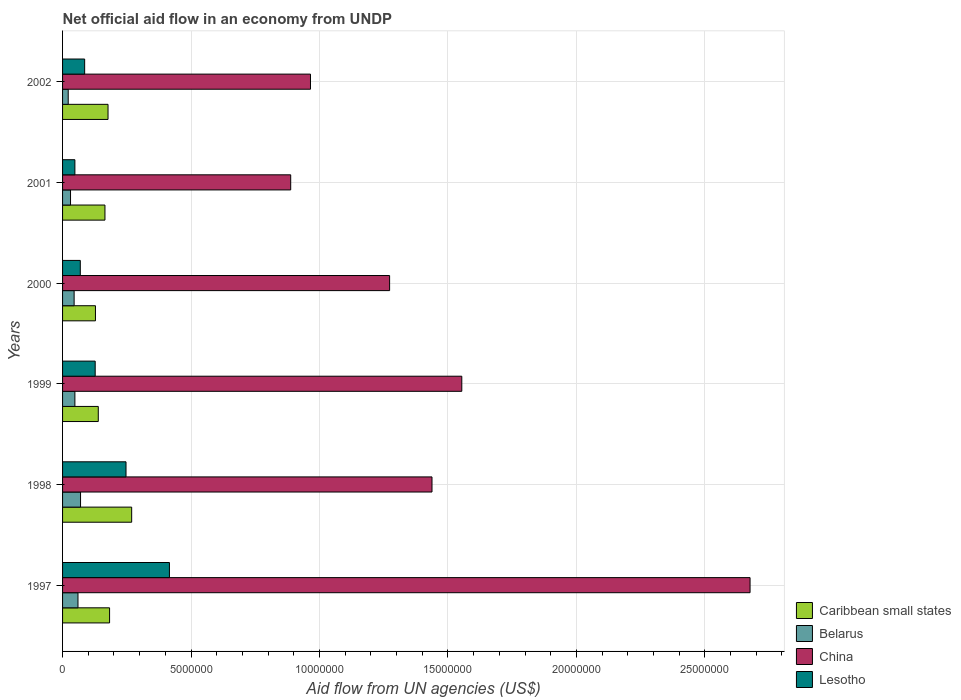How many different coloured bars are there?
Offer a very short reply. 4. Are the number of bars per tick equal to the number of legend labels?
Offer a very short reply. Yes. Are the number of bars on each tick of the Y-axis equal?
Your answer should be compact. Yes. How many bars are there on the 1st tick from the top?
Provide a short and direct response. 4. What is the net official aid flow in Lesotho in 1997?
Offer a terse response. 4.16e+06. Across all years, what is the maximum net official aid flow in China?
Your answer should be very brief. 2.68e+07. Across all years, what is the minimum net official aid flow in Caribbean small states?
Ensure brevity in your answer.  1.28e+06. What is the total net official aid flow in Lesotho in the graph?
Keep it short and to the point. 9.93e+06. What is the difference between the net official aid flow in Lesotho in 1999 and that in 2000?
Ensure brevity in your answer.  5.80e+05. What is the difference between the net official aid flow in China in 1999 and the net official aid flow in Lesotho in 2002?
Give a very brief answer. 1.47e+07. What is the average net official aid flow in China per year?
Ensure brevity in your answer.  1.47e+07. In the year 2001, what is the difference between the net official aid flow in Lesotho and net official aid flow in China?
Provide a succinct answer. -8.40e+06. In how many years, is the net official aid flow in China greater than 13000000 US$?
Give a very brief answer. 3. What is the ratio of the net official aid flow in China in 1997 to that in 2000?
Give a very brief answer. 2.1. Is the net official aid flow in Lesotho in 1998 less than that in 1999?
Keep it short and to the point. No. What is the difference between the highest and the second highest net official aid flow in China?
Give a very brief answer. 1.12e+07. What is the difference between the highest and the lowest net official aid flow in Caribbean small states?
Ensure brevity in your answer.  1.41e+06. In how many years, is the net official aid flow in Belarus greater than the average net official aid flow in Belarus taken over all years?
Your response must be concise. 3. Is the sum of the net official aid flow in Caribbean small states in 1998 and 2001 greater than the maximum net official aid flow in China across all years?
Make the answer very short. No. What does the 2nd bar from the top in 1998 represents?
Provide a short and direct response. China. How many bars are there?
Provide a short and direct response. 24. Are all the bars in the graph horizontal?
Your response must be concise. Yes. What is the difference between two consecutive major ticks on the X-axis?
Your answer should be very brief. 5.00e+06. What is the title of the graph?
Give a very brief answer. Net official aid flow in an economy from UNDP. Does "Hungary" appear as one of the legend labels in the graph?
Your answer should be compact. No. What is the label or title of the X-axis?
Your answer should be compact. Aid flow from UN agencies (US$). What is the label or title of the Y-axis?
Provide a short and direct response. Years. What is the Aid flow from UN agencies (US$) of Caribbean small states in 1997?
Provide a succinct answer. 1.83e+06. What is the Aid flow from UN agencies (US$) of China in 1997?
Your answer should be very brief. 2.68e+07. What is the Aid flow from UN agencies (US$) in Lesotho in 1997?
Your response must be concise. 4.16e+06. What is the Aid flow from UN agencies (US$) in Caribbean small states in 1998?
Your answer should be compact. 2.69e+06. What is the Aid flow from UN agencies (US$) in Belarus in 1998?
Ensure brevity in your answer.  7.00e+05. What is the Aid flow from UN agencies (US$) in China in 1998?
Keep it short and to the point. 1.44e+07. What is the Aid flow from UN agencies (US$) in Lesotho in 1998?
Keep it short and to the point. 2.47e+06. What is the Aid flow from UN agencies (US$) of Caribbean small states in 1999?
Provide a short and direct response. 1.39e+06. What is the Aid flow from UN agencies (US$) in Belarus in 1999?
Your response must be concise. 4.80e+05. What is the Aid flow from UN agencies (US$) of China in 1999?
Offer a terse response. 1.55e+07. What is the Aid flow from UN agencies (US$) of Lesotho in 1999?
Give a very brief answer. 1.27e+06. What is the Aid flow from UN agencies (US$) in Caribbean small states in 2000?
Your answer should be very brief. 1.28e+06. What is the Aid flow from UN agencies (US$) in China in 2000?
Provide a succinct answer. 1.27e+07. What is the Aid flow from UN agencies (US$) of Lesotho in 2000?
Give a very brief answer. 6.90e+05. What is the Aid flow from UN agencies (US$) of Caribbean small states in 2001?
Your response must be concise. 1.65e+06. What is the Aid flow from UN agencies (US$) of Belarus in 2001?
Your answer should be compact. 3.10e+05. What is the Aid flow from UN agencies (US$) in China in 2001?
Make the answer very short. 8.88e+06. What is the Aid flow from UN agencies (US$) of Lesotho in 2001?
Your response must be concise. 4.80e+05. What is the Aid flow from UN agencies (US$) of Caribbean small states in 2002?
Offer a very short reply. 1.77e+06. What is the Aid flow from UN agencies (US$) of Belarus in 2002?
Your answer should be compact. 2.20e+05. What is the Aid flow from UN agencies (US$) in China in 2002?
Give a very brief answer. 9.65e+06. What is the Aid flow from UN agencies (US$) of Lesotho in 2002?
Provide a succinct answer. 8.60e+05. Across all years, what is the maximum Aid flow from UN agencies (US$) of Caribbean small states?
Offer a very short reply. 2.69e+06. Across all years, what is the maximum Aid flow from UN agencies (US$) in China?
Offer a terse response. 2.68e+07. Across all years, what is the maximum Aid flow from UN agencies (US$) in Lesotho?
Provide a succinct answer. 4.16e+06. Across all years, what is the minimum Aid flow from UN agencies (US$) of Caribbean small states?
Offer a very short reply. 1.28e+06. Across all years, what is the minimum Aid flow from UN agencies (US$) of Belarus?
Provide a succinct answer. 2.20e+05. Across all years, what is the minimum Aid flow from UN agencies (US$) in China?
Give a very brief answer. 8.88e+06. What is the total Aid flow from UN agencies (US$) in Caribbean small states in the graph?
Offer a terse response. 1.06e+07. What is the total Aid flow from UN agencies (US$) of Belarus in the graph?
Make the answer very short. 2.76e+06. What is the total Aid flow from UN agencies (US$) in China in the graph?
Provide a short and direct response. 8.79e+07. What is the total Aid flow from UN agencies (US$) of Lesotho in the graph?
Provide a short and direct response. 9.93e+06. What is the difference between the Aid flow from UN agencies (US$) in Caribbean small states in 1997 and that in 1998?
Keep it short and to the point. -8.60e+05. What is the difference between the Aid flow from UN agencies (US$) in China in 1997 and that in 1998?
Your response must be concise. 1.24e+07. What is the difference between the Aid flow from UN agencies (US$) of Lesotho in 1997 and that in 1998?
Ensure brevity in your answer.  1.69e+06. What is the difference between the Aid flow from UN agencies (US$) in China in 1997 and that in 1999?
Your answer should be very brief. 1.12e+07. What is the difference between the Aid flow from UN agencies (US$) in Lesotho in 1997 and that in 1999?
Provide a succinct answer. 2.89e+06. What is the difference between the Aid flow from UN agencies (US$) in Caribbean small states in 1997 and that in 2000?
Provide a succinct answer. 5.50e+05. What is the difference between the Aid flow from UN agencies (US$) in China in 1997 and that in 2000?
Your answer should be very brief. 1.40e+07. What is the difference between the Aid flow from UN agencies (US$) of Lesotho in 1997 and that in 2000?
Offer a very short reply. 3.47e+06. What is the difference between the Aid flow from UN agencies (US$) of Caribbean small states in 1997 and that in 2001?
Ensure brevity in your answer.  1.80e+05. What is the difference between the Aid flow from UN agencies (US$) in Belarus in 1997 and that in 2001?
Your response must be concise. 2.90e+05. What is the difference between the Aid flow from UN agencies (US$) of China in 1997 and that in 2001?
Offer a very short reply. 1.79e+07. What is the difference between the Aid flow from UN agencies (US$) in Lesotho in 1997 and that in 2001?
Ensure brevity in your answer.  3.68e+06. What is the difference between the Aid flow from UN agencies (US$) of China in 1997 and that in 2002?
Provide a succinct answer. 1.71e+07. What is the difference between the Aid flow from UN agencies (US$) in Lesotho in 1997 and that in 2002?
Give a very brief answer. 3.30e+06. What is the difference between the Aid flow from UN agencies (US$) of Caribbean small states in 1998 and that in 1999?
Keep it short and to the point. 1.30e+06. What is the difference between the Aid flow from UN agencies (US$) in China in 1998 and that in 1999?
Provide a short and direct response. -1.16e+06. What is the difference between the Aid flow from UN agencies (US$) in Lesotho in 1998 and that in 1999?
Provide a succinct answer. 1.20e+06. What is the difference between the Aid flow from UN agencies (US$) in Caribbean small states in 1998 and that in 2000?
Give a very brief answer. 1.41e+06. What is the difference between the Aid flow from UN agencies (US$) in Belarus in 1998 and that in 2000?
Provide a short and direct response. 2.50e+05. What is the difference between the Aid flow from UN agencies (US$) in China in 1998 and that in 2000?
Keep it short and to the point. 1.65e+06. What is the difference between the Aid flow from UN agencies (US$) in Lesotho in 1998 and that in 2000?
Make the answer very short. 1.78e+06. What is the difference between the Aid flow from UN agencies (US$) of Caribbean small states in 1998 and that in 2001?
Offer a very short reply. 1.04e+06. What is the difference between the Aid flow from UN agencies (US$) in China in 1998 and that in 2001?
Make the answer very short. 5.50e+06. What is the difference between the Aid flow from UN agencies (US$) of Lesotho in 1998 and that in 2001?
Your answer should be very brief. 1.99e+06. What is the difference between the Aid flow from UN agencies (US$) in Caribbean small states in 1998 and that in 2002?
Offer a very short reply. 9.20e+05. What is the difference between the Aid flow from UN agencies (US$) in China in 1998 and that in 2002?
Your answer should be very brief. 4.73e+06. What is the difference between the Aid flow from UN agencies (US$) in Lesotho in 1998 and that in 2002?
Provide a succinct answer. 1.61e+06. What is the difference between the Aid flow from UN agencies (US$) in Belarus in 1999 and that in 2000?
Your answer should be very brief. 3.00e+04. What is the difference between the Aid flow from UN agencies (US$) in China in 1999 and that in 2000?
Offer a very short reply. 2.81e+06. What is the difference between the Aid flow from UN agencies (US$) of Lesotho in 1999 and that in 2000?
Your answer should be very brief. 5.80e+05. What is the difference between the Aid flow from UN agencies (US$) in China in 1999 and that in 2001?
Offer a terse response. 6.66e+06. What is the difference between the Aid flow from UN agencies (US$) in Lesotho in 1999 and that in 2001?
Your answer should be very brief. 7.90e+05. What is the difference between the Aid flow from UN agencies (US$) in Caribbean small states in 1999 and that in 2002?
Provide a short and direct response. -3.80e+05. What is the difference between the Aid flow from UN agencies (US$) in China in 1999 and that in 2002?
Provide a succinct answer. 5.89e+06. What is the difference between the Aid flow from UN agencies (US$) in Caribbean small states in 2000 and that in 2001?
Your response must be concise. -3.70e+05. What is the difference between the Aid flow from UN agencies (US$) in Belarus in 2000 and that in 2001?
Offer a very short reply. 1.40e+05. What is the difference between the Aid flow from UN agencies (US$) in China in 2000 and that in 2001?
Your answer should be very brief. 3.85e+06. What is the difference between the Aid flow from UN agencies (US$) of Caribbean small states in 2000 and that in 2002?
Offer a terse response. -4.90e+05. What is the difference between the Aid flow from UN agencies (US$) of Belarus in 2000 and that in 2002?
Your response must be concise. 2.30e+05. What is the difference between the Aid flow from UN agencies (US$) in China in 2000 and that in 2002?
Make the answer very short. 3.08e+06. What is the difference between the Aid flow from UN agencies (US$) of China in 2001 and that in 2002?
Keep it short and to the point. -7.70e+05. What is the difference between the Aid flow from UN agencies (US$) of Lesotho in 2001 and that in 2002?
Offer a terse response. -3.80e+05. What is the difference between the Aid flow from UN agencies (US$) of Caribbean small states in 1997 and the Aid flow from UN agencies (US$) of Belarus in 1998?
Give a very brief answer. 1.13e+06. What is the difference between the Aid flow from UN agencies (US$) of Caribbean small states in 1997 and the Aid flow from UN agencies (US$) of China in 1998?
Your answer should be very brief. -1.26e+07. What is the difference between the Aid flow from UN agencies (US$) of Caribbean small states in 1997 and the Aid flow from UN agencies (US$) of Lesotho in 1998?
Make the answer very short. -6.40e+05. What is the difference between the Aid flow from UN agencies (US$) in Belarus in 1997 and the Aid flow from UN agencies (US$) in China in 1998?
Provide a succinct answer. -1.38e+07. What is the difference between the Aid flow from UN agencies (US$) in Belarus in 1997 and the Aid flow from UN agencies (US$) in Lesotho in 1998?
Provide a succinct answer. -1.87e+06. What is the difference between the Aid flow from UN agencies (US$) of China in 1997 and the Aid flow from UN agencies (US$) of Lesotho in 1998?
Your response must be concise. 2.43e+07. What is the difference between the Aid flow from UN agencies (US$) of Caribbean small states in 1997 and the Aid flow from UN agencies (US$) of Belarus in 1999?
Give a very brief answer. 1.35e+06. What is the difference between the Aid flow from UN agencies (US$) of Caribbean small states in 1997 and the Aid flow from UN agencies (US$) of China in 1999?
Your answer should be compact. -1.37e+07. What is the difference between the Aid flow from UN agencies (US$) in Caribbean small states in 1997 and the Aid flow from UN agencies (US$) in Lesotho in 1999?
Provide a short and direct response. 5.60e+05. What is the difference between the Aid flow from UN agencies (US$) in Belarus in 1997 and the Aid flow from UN agencies (US$) in China in 1999?
Your response must be concise. -1.49e+07. What is the difference between the Aid flow from UN agencies (US$) in Belarus in 1997 and the Aid flow from UN agencies (US$) in Lesotho in 1999?
Give a very brief answer. -6.70e+05. What is the difference between the Aid flow from UN agencies (US$) of China in 1997 and the Aid flow from UN agencies (US$) of Lesotho in 1999?
Offer a very short reply. 2.55e+07. What is the difference between the Aid flow from UN agencies (US$) in Caribbean small states in 1997 and the Aid flow from UN agencies (US$) in Belarus in 2000?
Your answer should be compact. 1.38e+06. What is the difference between the Aid flow from UN agencies (US$) in Caribbean small states in 1997 and the Aid flow from UN agencies (US$) in China in 2000?
Give a very brief answer. -1.09e+07. What is the difference between the Aid flow from UN agencies (US$) of Caribbean small states in 1997 and the Aid flow from UN agencies (US$) of Lesotho in 2000?
Your response must be concise. 1.14e+06. What is the difference between the Aid flow from UN agencies (US$) in Belarus in 1997 and the Aid flow from UN agencies (US$) in China in 2000?
Your answer should be very brief. -1.21e+07. What is the difference between the Aid flow from UN agencies (US$) of Belarus in 1997 and the Aid flow from UN agencies (US$) of Lesotho in 2000?
Make the answer very short. -9.00e+04. What is the difference between the Aid flow from UN agencies (US$) of China in 1997 and the Aid flow from UN agencies (US$) of Lesotho in 2000?
Keep it short and to the point. 2.61e+07. What is the difference between the Aid flow from UN agencies (US$) in Caribbean small states in 1997 and the Aid flow from UN agencies (US$) in Belarus in 2001?
Keep it short and to the point. 1.52e+06. What is the difference between the Aid flow from UN agencies (US$) in Caribbean small states in 1997 and the Aid flow from UN agencies (US$) in China in 2001?
Provide a short and direct response. -7.05e+06. What is the difference between the Aid flow from UN agencies (US$) of Caribbean small states in 1997 and the Aid flow from UN agencies (US$) of Lesotho in 2001?
Your answer should be very brief. 1.35e+06. What is the difference between the Aid flow from UN agencies (US$) in Belarus in 1997 and the Aid flow from UN agencies (US$) in China in 2001?
Ensure brevity in your answer.  -8.28e+06. What is the difference between the Aid flow from UN agencies (US$) of China in 1997 and the Aid flow from UN agencies (US$) of Lesotho in 2001?
Your answer should be very brief. 2.63e+07. What is the difference between the Aid flow from UN agencies (US$) of Caribbean small states in 1997 and the Aid flow from UN agencies (US$) of Belarus in 2002?
Make the answer very short. 1.61e+06. What is the difference between the Aid flow from UN agencies (US$) in Caribbean small states in 1997 and the Aid flow from UN agencies (US$) in China in 2002?
Your answer should be compact. -7.82e+06. What is the difference between the Aid flow from UN agencies (US$) of Caribbean small states in 1997 and the Aid flow from UN agencies (US$) of Lesotho in 2002?
Offer a very short reply. 9.70e+05. What is the difference between the Aid flow from UN agencies (US$) of Belarus in 1997 and the Aid flow from UN agencies (US$) of China in 2002?
Offer a very short reply. -9.05e+06. What is the difference between the Aid flow from UN agencies (US$) in China in 1997 and the Aid flow from UN agencies (US$) in Lesotho in 2002?
Your response must be concise. 2.59e+07. What is the difference between the Aid flow from UN agencies (US$) of Caribbean small states in 1998 and the Aid flow from UN agencies (US$) of Belarus in 1999?
Give a very brief answer. 2.21e+06. What is the difference between the Aid flow from UN agencies (US$) in Caribbean small states in 1998 and the Aid flow from UN agencies (US$) in China in 1999?
Offer a very short reply. -1.28e+07. What is the difference between the Aid flow from UN agencies (US$) in Caribbean small states in 1998 and the Aid flow from UN agencies (US$) in Lesotho in 1999?
Provide a succinct answer. 1.42e+06. What is the difference between the Aid flow from UN agencies (US$) in Belarus in 1998 and the Aid flow from UN agencies (US$) in China in 1999?
Provide a short and direct response. -1.48e+07. What is the difference between the Aid flow from UN agencies (US$) of Belarus in 1998 and the Aid flow from UN agencies (US$) of Lesotho in 1999?
Your answer should be compact. -5.70e+05. What is the difference between the Aid flow from UN agencies (US$) in China in 1998 and the Aid flow from UN agencies (US$) in Lesotho in 1999?
Offer a terse response. 1.31e+07. What is the difference between the Aid flow from UN agencies (US$) of Caribbean small states in 1998 and the Aid flow from UN agencies (US$) of Belarus in 2000?
Give a very brief answer. 2.24e+06. What is the difference between the Aid flow from UN agencies (US$) in Caribbean small states in 1998 and the Aid flow from UN agencies (US$) in China in 2000?
Provide a succinct answer. -1.00e+07. What is the difference between the Aid flow from UN agencies (US$) of Belarus in 1998 and the Aid flow from UN agencies (US$) of China in 2000?
Keep it short and to the point. -1.20e+07. What is the difference between the Aid flow from UN agencies (US$) of China in 1998 and the Aid flow from UN agencies (US$) of Lesotho in 2000?
Your answer should be very brief. 1.37e+07. What is the difference between the Aid flow from UN agencies (US$) of Caribbean small states in 1998 and the Aid flow from UN agencies (US$) of Belarus in 2001?
Provide a short and direct response. 2.38e+06. What is the difference between the Aid flow from UN agencies (US$) of Caribbean small states in 1998 and the Aid flow from UN agencies (US$) of China in 2001?
Give a very brief answer. -6.19e+06. What is the difference between the Aid flow from UN agencies (US$) in Caribbean small states in 1998 and the Aid flow from UN agencies (US$) in Lesotho in 2001?
Your answer should be very brief. 2.21e+06. What is the difference between the Aid flow from UN agencies (US$) of Belarus in 1998 and the Aid flow from UN agencies (US$) of China in 2001?
Offer a terse response. -8.18e+06. What is the difference between the Aid flow from UN agencies (US$) in China in 1998 and the Aid flow from UN agencies (US$) in Lesotho in 2001?
Your answer should be compact. 1.39e+07. What is the difference between the Aid flow from UN agencies (US$) in Caribbean small states in 1998 and the Aid flow from UN agencies (US$) in Belarus in 2002?
Your answer should be compact. 2.47e+06. What is the difference between the Aid flow from UN agencies (US$) of Caribbean small states in 1998 and the Aid flow from UN agencies (US$) of China in 2002?
Give a very brief answer. -6.96e+06. What is the difference between the Aid flow from UN agencies (US$) of Caribbean small states in 1998 and the Aid flow from UN agencies (US$) of Lesotho in 2002?
Provide a succinct answer. 1.83e+06. What is the difference between the Aid flow from UN agencies (US$) of Belarus in 1998 and the Aid flow from UN agencies (US$) of China in 2002?
Give a very brief answer. -8.95e+06. What is the difference between the Aid flow from UN agencies (US$) of China in 1998 and the Aid flow from UN agencies (US$) of Lesotho in 2002?
Keep it short and to the point. 1.35e+07. What is the difference between the Aid flow from UN agencies (US$) of Caribbean small states in 1999 and the Aid flow from UN agencies (US$) of Belarus in 2000?
Provide a succinct answer. 9.40e+05. What is the difference between the Aid flow from UN agencies (US$) of Caribbean small states in 1999 and the Aid flow from UN agencies (US$) of China in 2000?
Offer a terse response. -1.13e+07. What is the difference between the Aid flow from UN agencies (US$) in Caribbean small states in 1999 and the Aid flow from UN agencies (US$) in Lesotho in 2000?
Keep it short and to the point. 7.00e+05. What is the difference between the Aid flow from UN agencies (US$) of Belarus in 1999 and the Aid flow from UN agencies (US$) of China in 2000?
Your answer should be very brief. -1.22e+07. What is the difference between the Aid flow from UN agencies (US$) in Belarus in 1999 and the Aid flow from UN agencies (US$) in Lesotho in 2000?
Offer a very short reply. -2.10e+05. What is the difference between the Aid flow from UN agencies (US$) of China in 1999 and the Aid flow from UN agencies (US$) of Lesotho in 2000?
Provide a short and direct response. 1.48e+07. What is the difference between the Aid flow from UN agencies (US$) in Caribbean small states in 1999 and the Aid flow from UN agencies (US$) in Belarus in 2001?
Give a very brief answer. 1.08e+06. What is the difference between the Aid flow from UN agencies (US$) of Caribbean small states in 1999 and the Aid flow from UN agencies (US$) of China in 2001?
Give a very brief answer. -7.49e+06. What is the difference between the Aid flow from UN agencies (US$) of Caribbean small states in 1999 and the Aid flow from UN agencies (US$) of Lesotho in 2001?
Ensure brevity in your answer.  9.10e+05. What is the difference between the Aid flow from UN agencies (US$) of Belarus in 1999 and the Aid flow from UN agencies (US$) of China in 2001?
Keep it short and to the point. -8.40e+06. What is the difference between the Aid flow from UN agencies (US$) in China in 1999 and the Aid flow from UN agencies (US$) in Lesotho in 2001?
Your response must be concise. 1.51e+07. What is the difference between the Aid flow from UN agencies (US$) of Caribbean small states in 1999 and the Aid flow from UN agencies (US$) of Belarus in 2002?
Ensure brevity in your answer.  1.17e+06. What is the difference between the Aid flow from UN agencies (US$) in Caribbean small states in 1999 and the Aid flow from UN agencies (US$) in China in 2002?
Your response must be concise. -8.26e+06. What is the difference between the Aid flow from UN agencies (US$) of Caribbean small states in 1999 and the Aid flow from UN agencies (US$) of Lesotho in 2002?
Offer a very short reply. 5.30e+05. What is the difference between the Aid flow from UN agencies (US$) in Belarus in 1999 and the Aid flow from UN agencies (US$) in China in 2002?
Your answer should be compact. -9.17e+06. What is the difference between the Aid flow from UN agencies (US$) of Belarus in 1999 and the Aid flow from UN agencies (US$) of Lesotho in 2002?
Keep it short and to the point. -3.80e+05. What is the difference between the Aid flow from UN agencies (US$) of China in 1999 and the Aid flow from UN agencies (US$) of Lesotho in 2002?
Give a very brief answer. 1.47e+07. What is the difference between the Aid flow from UN agencies (US$) in Caribbean small states in 2000 and the Aid flow from UN agencies (US$) in Belarus in 2001?
Make the answer very short. 9.70e+05. What is the difference between the Aid flow from UN agencies (US$) of Caribbean small states in 2000 and the Aid flow from UN agencies (US$) of China in 2001?
Offer a very short reply. -7.60e+06. What is the difference between the Aid flow from UN agencies (US$) in Caribbean small states in 2000 and the Aid flow from UN agencies (US$) in Lesotho in 2001?
Ensure brevity in your answer.  8.00e+05. What is the difference between the Aid flow from UN agencies (US$) in Belarus in 2000 and the Aid flow from UN agencies (US$) in China in 2001?
Your answer should be compact. -8.43e+06. What is the difference between the Aid flow from UN agencies (US$) in China in 2000 and the Aid flow from UN agencies (US$) in Lesotho in 2001?
Give a very brief answer. 1.22e+07. What is the difference between the Aid flow from UN agencies (US$) of Caribbean small states in 2000 and the Aid flow from UN agencies (US$) of Belarus in 2002?
Provide a short and direct response. 1.06e+06. What is the difference between the Aid flow from UN agencies (US$) in Caribbean small states in 2000 and the Aid flow from UN agencies (US$) in China in 2002?
Your response must be concise. -8.37e+06. What is the difference between the Aid flow from UN agencies (US$) in Caribbean small states in 2000 and the Aid flow from UN agencies (US$) in Lesotho in 2002?
Make the answer very short. 4.20e+05. What is the difference between the Aid flow from UN agencies (US$) of Belarus in 2000 and the Aid flow from UN agencies (US$) of China in 2002?
Your answer should be compact. -9.20e+06. What is the difference between the Aid flow from UN agencies (US$) of Belarus in 2000 and the Aid flow from UN agencies (US$) of Lesotho in 2002?
Provide a succinct answer. -4.10e+05. What is the difference between the Aid flow from UN agencies (US$) in China in 2000 and the Aid flow from UN agencies (US$) in Lesotho in 2002?
Your answer should be compact. 1.19e+07. What is the difference between the Aid flow from UN agencies (US$) in Caribbean small states in 2001 and the Aid flow from UN agencies (US$) in Belarus in 2002?
Make the answer very short. 1.43e+06. What is the difference between the Aid flow from UN agencies (US$) in Caribbean small states in 2001 and the Aid flow from UN agencies (US$) in China in 2002?
Make the answer very short. -8.00e+06. What is the difference between the Aid flow from UN agencies (US$) in Caribbean small states in 2001 and the Aid flow from UN agencies (US$) in Lesotho in 2002?
Ensure brevity in your answer.  7.90e+05. What is the difference between the Aid flow from UN agencies (US$) in Belarus in 2001 and the Aid flow from UN agencies (US$) in China in 2002?
Ensure brevity in your answer.  -9.34e+06. What is the difference between the Aid flow from UN agencies (US$) in Belarus in 2001 and the Aid flow from UN agencies (US$) in Lesotho in 2002?
Provide a succinct answer. -5.50e+05. What is the difference between the Aid flow from UN agencies (US$) of China in 2001 and the Aid flow from UN agencies (US$) of Lesotho in 2002?
Ensure brevity in your answer.  8.02e+06. What is the average Aid flow from UN agencies (US$) in Caribbean small states per year?
Ensure brevity in your answer.  1.77e+06. What is the average Aid flow from UN agencies (US$) of Belarus per year?
Your response must be concise. 4.60e+05. What is the average Aid flow from UN agencies (US$) in China per year?
Ensure brevity in your answer.  1.47e+07. What is the average Aid flow from UN agencies (US$) in Lesotho per year?
Offer a terse response. 1.66e+06. In the year 1997, what is the difference between the Aid flow from UN agencies (US$) in Caribbean small states and Aid flow from UN agencies (US$) in Belarus?
Your response must be concise. 1.23e+06. In the year 1997, what is the difference between the Aid flow from UN agencies (US$) of Caribbean small states and Aid flow from UN agencies (US$) of China?
Your answer should be compact. -2.49e+07. In the year 1997, what is the difference between the Aid flow from UN agencies (US$) in Caribbean small states and Aid flow from UN agencies (US$) in Lesotho?
Your answer should be very brief. -2.33e+06. In the year 1997, what is the difference between the Aid flow from UN agencies (US$) of Belarus and Aid flow from UN agencies (US$) of China?
Give a very brief answer. -2.62e+07. In the year 1997, what is the difference between the Aid flow from UN agencies (US$) in Belarus and Aid flow from UN agencies (US$) in Lesotho?
Offer a terse response. -3.56e+06. In the year 1997, what is the difference between the Aid flow from UN agencies (US$) of China and Aid flow from UN agencies (US$) of Lesotho?
Provide a succinct answer. 2.26e+07. In the year 1998, what is the difference between the Aid flow from UN agencies (US$) in Caribbean small states and Aid flow from UN agencies (US$) in Belarus?
Offer a very short reply. 1.99e+06. In the year 1998, what is the difference between the Aid flow from UN agencies (US$) of Caribbean small states and Aid flow from UN agencies (US$) of China?
Ensure brevity in your answer.  -1.17e+07. In the year 1998, what is the difference between the Aid flow from UN agencies (US$) in Caribbean small states and Aid flow from UN agencies (US$) in Lesotho?
Keep it short and to the point. 2.20e+05. In the year 1998, what is the difference between the Aid flow from UN agencies (US$) in Belarus and Aid flow from UN agencies (US$) in China?
Make the answer very short. -1.37e+07. In the year 1998, what is the difference between the Aid flow from UN agencies (US$) in Belarus and Aid flow from UN agencies (US$) in Lesotho?
Offer a terse response. -1.77e+06. In the year 1998, what is the difference between the Aid flow from UN agencies (US$) in China and Aid flow from UN agencies (US$) in Lesotho?
Your response must be concise. 1.19e+07. In the year 1999, what is the difference between the Aid flow from UN agencies (US$) in Caribbean small states and Aid flow from UN agencies (US$) in Belarus?
Your answer should be compact. 9.10e+05. In the year 1999, what is the difference between the Aid flow from UN agencies (US$) of Caribbean small states and Aid flow from UN agencies (US$) of China?
Ensure brevity in your answer.  -1.42e+07. In the year 1999, what is the difference between the Aid flow from UN agencies (US$) of Caribbean small states and Aid flow from UN agencies (US$) of Lesotho?
Keep it short and to the point. 1.20e+05. In the year 1999, what is the difference between the Aid flow from UN agencies (US$) in Belarus and Aid flow from UN agencies (US$) in China?
Make the answer very short. -1.51e+07. In the year 1999, what is the difference between the Aid flow from UN agencies (US$) of Belarus and Aid flow from UN agencies (US$) of Lesotho?
Your response must be concise. -7.90e+05. In the year 1999, what is the difference between the Aid flow from UN agencies (US$) of China and Aid flow from UN agencies (US$) of Lesotho?
Provide a short and direct response. 1.43e+07. In the year 2000, what is the difference between the Aid flow from UN agencies (US$) in Caribbean small states and Aid flow from UN agencies (US$) in Belarus?
Ensure brevity in your answer.  8.30e+05. In the year 2000, what is the difference between the Aid flow from UN agencies (US$) of Caribbean small states and Aid flow from UN agencies (US$) of China?
Provide a short and direct response. -1.14e+07. In the year 2000, what is the difference between the Aid flow from UN agencies (US$) of Caribbean small states and Aid flow from UN agencies (US$) of Lesotho?
Offer a terse response. 5.90e+05. In the year 2000, what is the difference between the Aid flow from UN agencies (US$) of Belarus and Aid flow from UN agencies (US$) of China?
Your answer should be very brief. -1.23e+07. In the year 2000, what is the difference between the Aid flow from UN agencies (US$) of China and Aid flow from UN agencies (US$) of Lesotho?
Keep it short and to the point. 1.20e+07. In the year 2001, what is the difference between the Aid flow from UN agencies (US$) of Caribbean small states and Aid flow from UN agencies (US$) of Belarus?
Your answer should be compact. 1.34e+06. In the year 2001, what is the difference between the Aid flow from UN agencies (US$) in Caribbean small states and Aid flow from UN agencies (US$) in China?
Offer a very short reply. -7.23e+06. In the year 2001, what is the difference between the Aid flow from UN agencies (US$) in Caribbean small states and Aid flow from UN agencies (US$) in Lesotho?
Offer a terse response. 1.17e+06. In the year 2001, what is the difference between the Aid flow from UN agencies (US$) of Belarus and Aid flow from UN agencies (US$) of China?
Keep it short and to the point. -8.57e+06. In the year 2001, what is the difference between the Aid flow from UN agencies (US$) in Belarus and Aid flow from UN agencies (US$) in Lesotho?
Give a very brief answer. -1.70e+05. In the year 2001, what is the difference between the Aid flow from UN agencies (US$) of China and Aid flow from UN agencies (US$) of Lesotho?
Your answer should be compact. 8.40e+06. In the year 2002, what is the difference between the Aid flow from UN agencies (US$) in Caribbean small states and Aid flow from UN agencies (US$) in Belarus?
Ensure brevity in your answer.  1.55e+06. In the year 2002, what is the difference between the Aid flow from UN agencies (US$) in Caribbean small states and Aid flow from UN agencies (US$) in China?
Your answer should be very brief. -7.88e+06. In the year 2002, what is the difference between the Aid flow from UN agencies (US$) of Caribbean small states and Aid flow from UN agencies (US$) of Lesotho?
Ensure brevity in your answer.  9.10e+05. In the year 2002, what is the difference between the Aid flow from UN agencies (US$) of Belarus and Aid flow from UN agencies (US$) of China?
Offer a very short reply. -9.43e+06. In the year 2002, what is the difference between the Aid flow from UN agencies (US$) in Belarus and Aid flow from UN agencies (US$) in Lesotho?
Your answer should be compact. -6.40e+05. In the year 2002, what is the difference between the Aid flow from UN agencies (US$) in China and Aid flow from UN agencies (US$) in Lesotho?
Provide a succinct answer. 8.79e+06. What is the ratio of the Aid flow from UN agencies (US$) of Caribbean small states in 1997 to that in 1998?
Make the answer very short. 0.68. What is the ratio of the Aid flow from UN agencies (US$) in China in 1997 to that in 1998?
Your answer should be compact. 1.86. What is the ratio of the Aid flow from UN agencies (US$) in Lesotho in 1997 to that in 1998?
Make the answer very short. 1.68. What is the ratio of the Aid flow from UN agencies (US$) of Caribbean small states in 1997 to that in 1999?
Your answer should be compact. 1.32. What is the ratio of the Aid flow from UN agencies (US$) in Belarus in 1997 to that in 1999?
Provide a succinct answer. 1.25. What is the ratio of the Aid flow from UN agencies (US$) in China in 1997 to that in 1999?
Offer a terse response. 1.72. What is the ratio of the Aid flow from UN agencies (US$) in Lesotho in 1997 to that in 1999?
Keep it short and to the point. 3.28. What is the ratio of the Aid flow from UN agencies (US$) of Caribbean small states in 1997 to that in 2000?
Offer a terse response. 1.43. What is the ratio of the Aid flow from UN agencies (US$) in China in 1997 to that in 2000?
Make the answer very short. 2.1. What is the ratio of the Aid flow from UN agencies (US$) in Lesotho in 1997 to that in 2000?
Keep it short and to the point. 6.03. What is the ratio of the Aid flow from UN agencies (US$) of Caribbean small states in 1997 to that in 2001?
Your response must be concise. 1.11. What is the ratio of the Aid flow from UN agencies (US$) in Belarus in 1997 to that in 2001?
Offer a terse response. 1.94. What is the ratio of the Aid flow from UN agencies (US$) of China in 1997 to that in 2001?
Your answer should be very brief. 3.01. What is the ratio of the Aid flow from UN agencies (US$) of Lesotho in 1997 to that in 2001?
Provide a short and direct response. 8.67. What is the ratio of the Aid flow from UN agencies (US$) of Caribbean small states in 1997 to that in 2002?
Make the answer very short. 1.03. What is the ratio of the Aid flow from UN agencies (US$) of Belarus in 1997 to that in 2002?
Provide a short and direct response. 2.73. What is the ratio of the Aid flow from UN agencies (US$) in China in 1997 to that in 2002?
Offer a very short reply. 2.77. What is the ratio of the Aid flow from UN agencies (US$) in Lesotho in 1997 to that in 2002?
Make the answer very short. 4.84. What is the ratio of the Aid flow from UN agencies (US$) of Caribbean small states in 1998 to that in 1999?
Provide a succinct answer. 1.94. What is the ratio of the Aid flow from UN agencies (US$) in Belarus in 1998 to that in 1999?
Provide a succinct answer. 1.46. What is the ratio of the Aid flow from UN agencies (US$) of China in 1998 to that in 1999?
Offer a very short reply. 0.93. What is the ratio of the Aid flow from UN agencies (US$) in Lesotho in 1998 to that in 1999?
Provide a succinct answer. 1.94. What is the ratio of the Aid flow from UN agencies (US$) in Caribbean small states in 1998 to that in 2000?
Ensure brevity in your answer.  2.1. What is the ratio of the Aid flow from UN agencies (US$) in Belarus in 1998 to that in 2000?
Offer a terse response. 1.56. What is the ratio of the Aid flow from UN agencies (US$) of China in 1998 to that in 2000?
Offer a terse response. 1.13. What is the ratio of the Aid flow from UN agencies (US$) of Lesotho in 1998 to that in 2000?
Give a very brief answer. 3.58. What is the ratio of the Aid flow from UN agencies (US$) in Caribbean small states in 1998 to that in 2001?
Provide a succinct answer. 1.63. What is the ratio of the Aid flow from UN agencies (US$) in Belarus in 1998 to that in 2001?
Provide a succinct answer. 2.26. What is the ratio of the Aid flow from UN agencies (US$) of China in 1998 to that in 2001?
Offer a very short reply. 1.62. What is the ratio of the Aid flow from UN agencies (US$) of Lesotho in 1998 to that in 2001?
Give a very brief answer. 5.15. What is the ratio of the Aid flow from UN agencies (US$) of Caribbean small states in 1998 to that in 2002?
Offer a terse response. 1.52. What is the ratio of the Aid flow from UN agencies (US$) in Belarus in 1998 to that in 2002?
Your answer should be very brief. 3.18. What is the ratio of the Aid flow from UN agencies (US$) in China in 1998 to that in 2002?
Your response must be concise. 1.49. What is the ratio of the Aid flow from UN agencies (US$) in Lesotho in 1998 to that in 2002?
Your answer should be compact. 2.87. What is the ratio of the Aid flow from UN agencies (US$) of Caribbean small states in 1999 to that in 2000?
Provide a succinct answer. 1.09. What is the ratio of the Aid flow from UN agencies (US$) in Belarus in 1999 to that in 2000?
Offer a very short reply. 1.07. What is the ratio of the Aid flow from UN agencies (US$) in China in 1999 to that in 2000?
Keep it short and to the point. 1.22. What is the ratio of the Aid flow from UN agencies (US$) in Lesotho in 1999 to that in 2000?
Offer a very short reply. 1.84. What is the ratio of the Aid flow from UN agencies (US$) of Caribbean small states in 1999 to that in 2001?
Keep it short and to the point. 0.84. What is the ratio of the Aid flow from UN agencies (US$) in Belarus in 1999 to that in 2001?
Your response must be concise. 1.55. What is the ratio of the Aid flow from UN agencies (US$) in Lesotho in 1999 to that in 2001?
Ensure brevity in your answer.  2.65. What is the ratio of the Aid flow from UN agencies (US$) of Caribbean small states in 1999 to that in 2002?
Your answer should be compact. 0.79. What is the ratio of the Aid flow from UN agencies (US$) in Belarus in 1999 to that in 2002?
Your response must be concise. 2.18. What is the ratio of the Aid flow from UN agencies (US$) in China in 1999 to that in 2002?
Ensure brevity in your answer.  1.61. What is the ratio of the Aid flow from UN agencies (US$) in Lesotho in 1999 to that in 2002?
Provide a short and direct response. 1.48. What is the ratio of the Aid flow from UN agencies (US$) of Caribbean small states in 2000 to that in 2001?
Keep it short and to the point. 0.78. What is the ratio of the Aid flow from UN agencies (US$) of Belarus in 2000 to that in 2001?
Make the answer very short. 1.45. What is the ratio of the Aid flow from UN agencies (US$) of China in 2000 to that in 2001?
Ensure brevity in your answer.  1.43. What is the ratio of the Aid flow from UN agencies (US$) in Lesotho in 2000 to that in 2001?
Your answer should be very brief. 1.44. What is the ratio of the Aid flow from UN agencies (US$) of Caribbean small states in 2000 to that in 2002?
Your answer should be compact. 0.72. What is the ratio of the Aid flow from UN agencies (US$) in Belarus in 2000 to that in 2002?
Your response must be concise. 2.05. What is the ratio of the Aid flow from UN agencies (US$) in China in 2000 to that in 2002?
Offer a very short reply. 1.32. What is the ratio of the Aid flow from UN agencies (US$) of Lesotho in 2000 to that in 2002?
Your response must be concise. 0.8. What is the ratio of the Aid flow from UN agencies (US$) in Caribbean small states in 2001 to that in 2002?
Provide a succinct answer. 0.93. What is the ratio of the Aid flow from UN agencies (US$) of Belarus in 2001 to that in 2002?
Your answer should be very brief. 1.41. What is the ratio of the Aid flow from UN agencies (US$) of China in 2001 to that in 2002?
Make the answer very short. 0.92. What is the ratio of the Aid flow from UN agencies (US$) of Lesotho in 2001 to that in 2002?
Provide a short and direct response. 0.56. What is the difference between the highest and the second highest Aid flow from UN agencies (US$) in Caribbean small states?
Your answer should be very brief. 8.60e+05. What is the difference between the highest and the second highest Aid flow from UN agencies (US$) of Belarus?
Your response must be concise. 1.00e+05. What is the difference between the highest and the second highest Aid flow from UN agencies (US$) of China?
Keep it short and to the point. 1.12e+07. What is the difference between the highest and the second highest Aid flow from UN agencies (US$) of Lesotho?
Your response must be concise. 1.69e+06. What is the difference between the highest and the lowest Aid flow from UN agencies (US$) of Caribbean small states?
Your answer should be compact. 1.41e+06. What is the difference between the highest and the lowest Aid flow from UN agencies (US$) of China?
Ensure brevity in your answer.  1.79e+07. What is the difference between the highest and the lowest Aid flow from UN agencies (US$) of Lesotho?
Your answer should be very brief. 3.68e+06. 